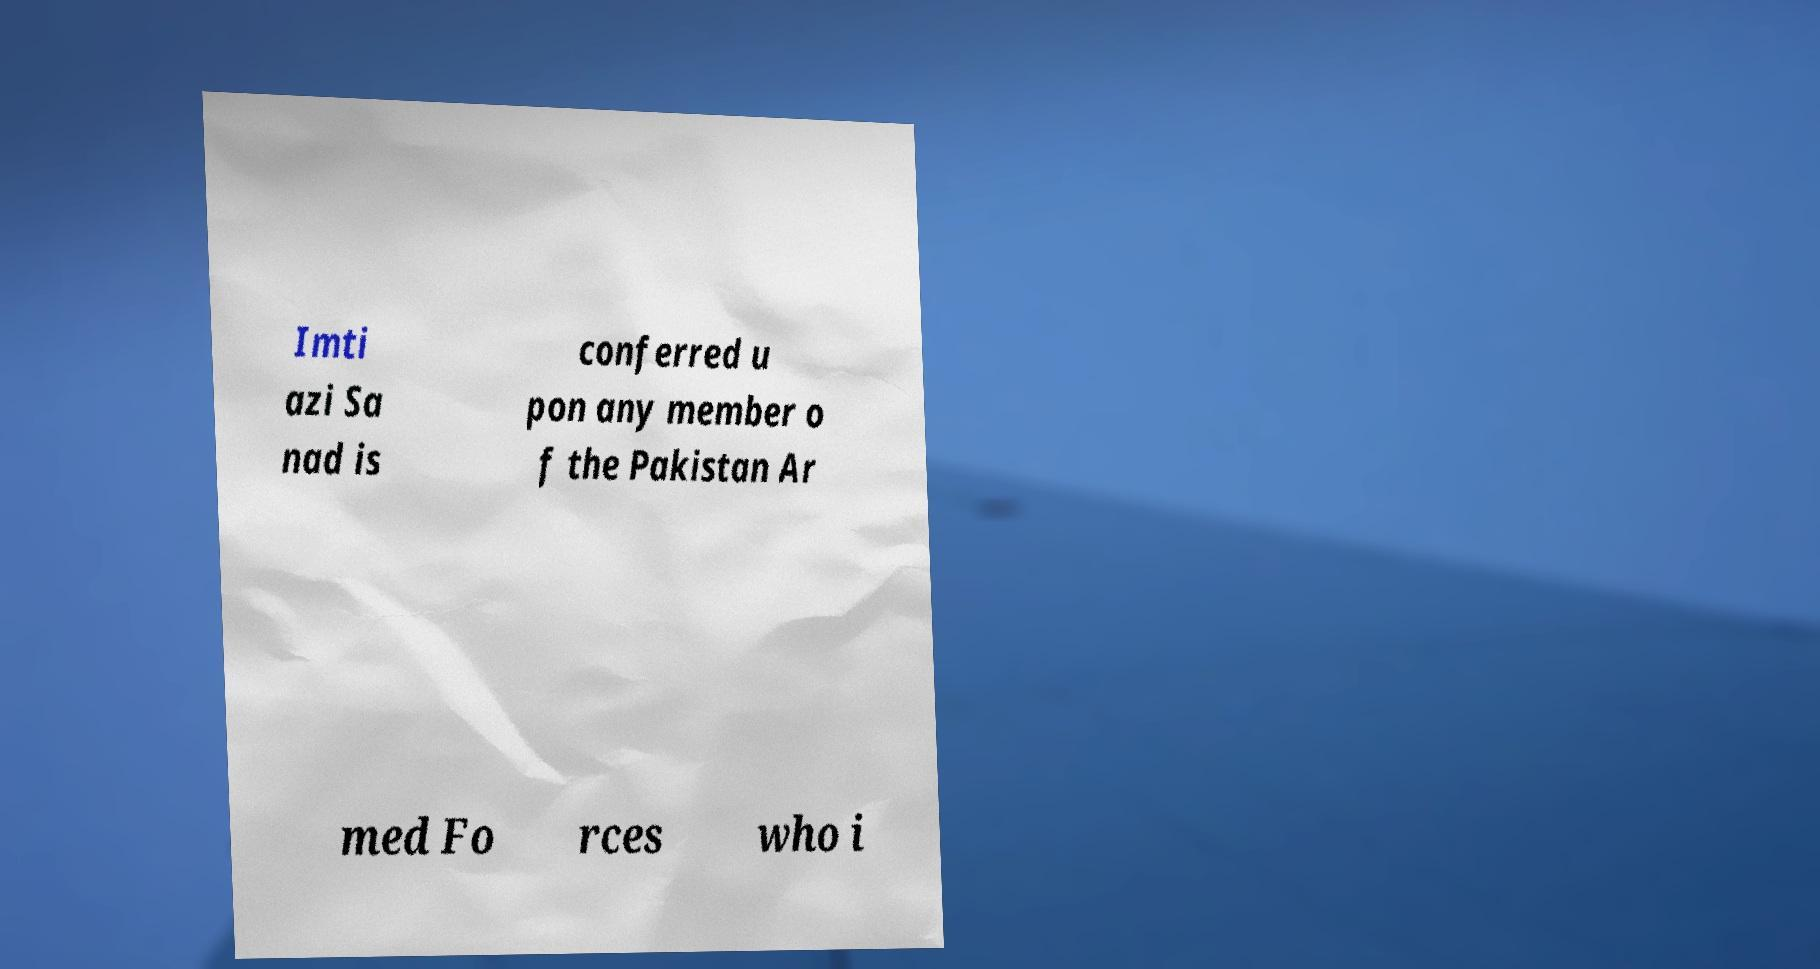Please read and relay the text visible in this image. What does it say? Imti azi Sa nad is conferred u pon any member o f the Pakistan Ar med Fo rces who i 